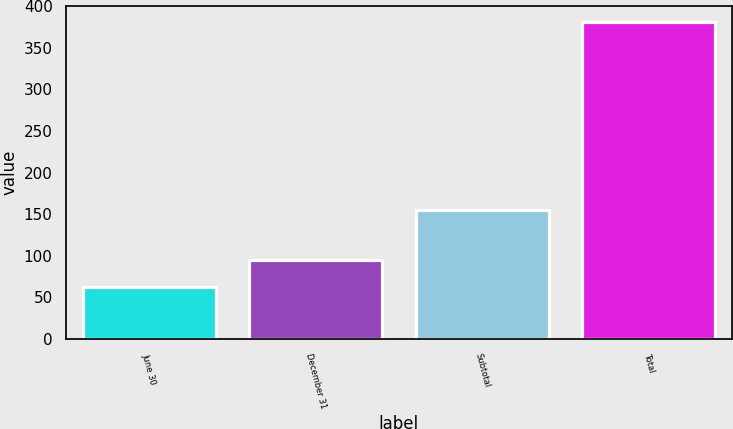Convert chart to OTSL. <chart><loc_0><loc_0><loc_500><loc_500><bar_chart><fcel>June 30<fcel>December 31<fcel>Subtotal<fcel>Total<nl><fcel>63<fcel>94.8<fcel>155<fcel>381<nl></chart> 